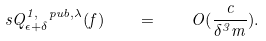<formula> <loc_0><loc_0><loc_500><loc_500>\ s Q ^ { 1 , \ p u b , \lambda } _ { \epsilon + \delta } ( f ) \quad = \quad O ( \frac { c } { \delta ^ { 3 } m } ) .</formula> 